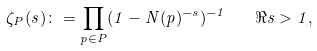<formula> <loc_0><loc_0><loc_500><loc_500>\zeta _ { P } ( s ) \colon = \prod _ { p \in P } ( 1 - N ( p ) ^ { - s } ) ^ { - 1 } \quad \Re { s } > 1 ,</formula> 